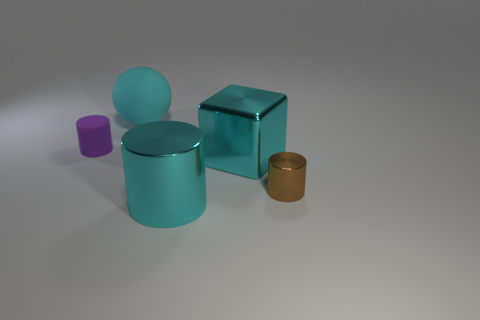Is there anything else that has the same material as the tiny brown thing?
Make the answer very short. Yes. What number of cubes are blue things or cyan rubber objects?
Give a very brief answer. 0. Are there any small red objects that have the same shape as the tiny brown shiny thing?
Provide a succinct answer. No. What is the shape of the small brown shiny object?
Your answer should be compact. Cylinder. What number of objects are brown things or matte things?
Keep it short and to the point. 3. Is the size of the shiny thing behind the brown cylinder the same as the matte thing to the left of the cyan matte ball?
Provide a short and direct response. No. What number of other things are made of the same material as the purple thing?
Offer a terse response. 1. Are there more brown objects in front of the cyan rubber ball than large metallic objects that are to the left of the purple rubber cylinder?
Keep it short and to the point. Yes. There is a thing that is left of the rubber ball; what is it made of?
Make the answer very short. Rubber. Does the tiny brown thing have the same shape as the purple matte thing?
Provide a short and direct response. Yes. 